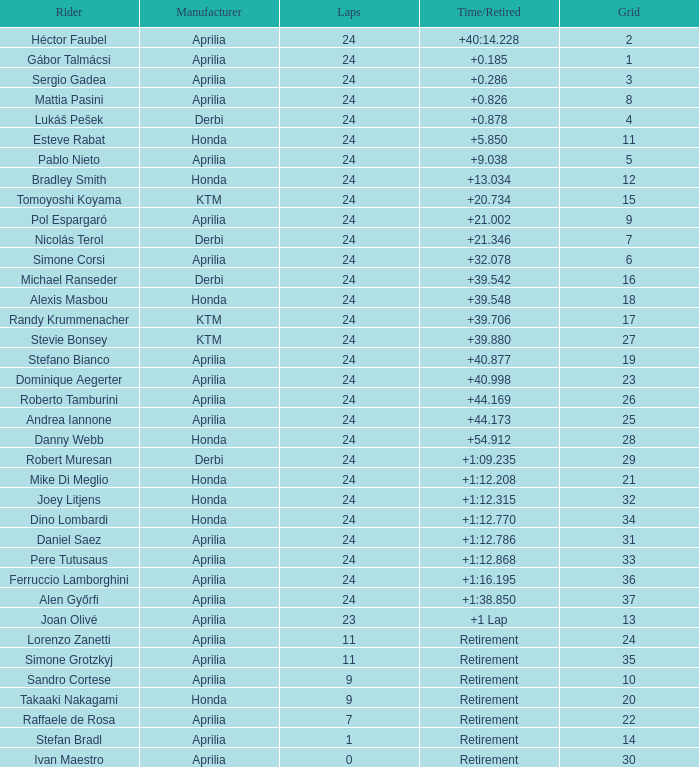How many grids have more than 24 laps with a time/retired of +1:12.208? None. 